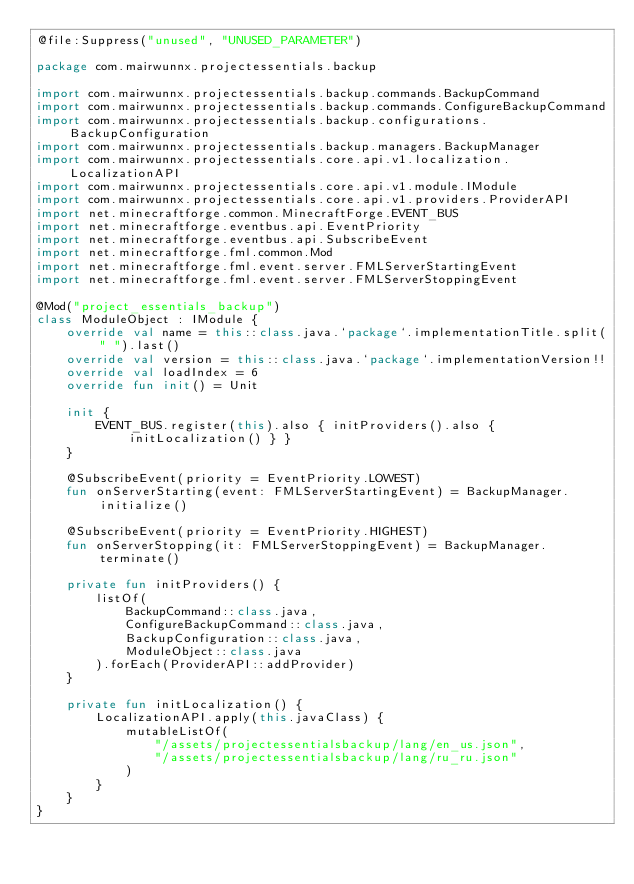<code> <loc_0><loc_0><loc_500><loc_500><_Kotlin_>@file:Suppress("unused", "UNUSED_PARAMETER")

package com.mairwunnx.projectessentials.backup

import com.mairwunnx.projectessentials.backup.commands.BackupCommand
import com.mairwunnx.projectessentials.backup.commands.ConfigureBackupCommand
import com.mairwunnx.projectessentials.backup.configurations.BackupConfiguration
import com.mairwunnx.projectessentials.backup.managers.BackupManager
import com.mairwunnx.projectessentials.core.api.v1.localization.LocalizationAPI
import com.mairwunnx.projectessentials.core.api.v1.module.IModule
import com.mairwunnx.projectessentials.core.api.v1.providers.ProviderAPI
import net.minecraftforge.common.MinecraftForge.EVENT_BUS
import net.minecraftforge.eventbus.api.EventPriority
import net.minecraftforge.eventbus.api.SubscribeEvent
import net.minecraftforge.fml.common.Mod
import net.minecraftforge.fml.event.server.FMLServerStartingEvent
import net.minecraftforge.fml.event.server.FMLServerStoppingEvent

@Mod("project_essentials_backup")
class ModuleObject : IModule {
    override val name = this::class.java.`package`.implementationTitle.split(" ").last()
    override val version = this::class.java.`package`.implementationVersion!!
    override val loadIndex = 6
    override fun init() = Unit

    init {
        EVENT_BUS.register(this).also { initProviders().also { initLocalization() } }
    }

    @SubscribeEvent(priority = EventPriority.LOWEST)
    fun onServerStarting(event: FMLServerStartingEvent) = BackupManager.initialize()

    @SubscribeEvent(priority = EventPriority.HIGHEST)
    fun onServerStopping(it: FMLServerStoppingEvent) = BackupManager.terminate()

    private fun initProviders() {
        listOf(
            BackupCommand::class.java,
            ConfigureBackupCommand::class.java,
            BackupConfiguration::class.java,
            ModuleObject::class.java
        ).forEach(ProviderAPI::addProvider)
    }

    private fun initLocalization() {
        LocalizationAPI.apply(this.javaClass) {
            mutableListOf(
                "/assets/projectessentialsbackup/lang/en_us.json",
                "/assets/projectessentialsbackup/lang/ru_ru.json"
            )
        }
    }
}
</code> 